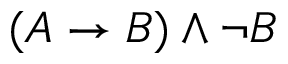<formula> <loc_0><loc_0><loc_500><loc_500>( A \to B ) \land \neg B</formula> 